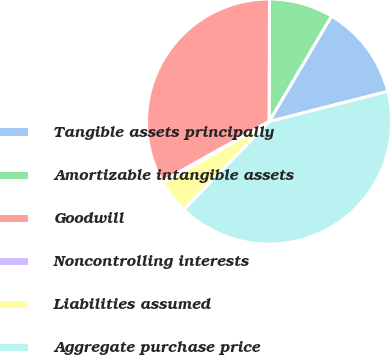<chart> <loc_0><loc_0><loc_500><loc_500><pie_chart><fcel>Tangible assets principally<fcel>Amortizable intangible assets<fcel>Goodwill<fcel>Noncontrolling interests<fcel>Liabilities assumed<fcel>Aggregate purchase price<nl><fcel>12.54%<fcel>8.45%<fcel>33.2%<fcel>0.26%<fcel>4.35%<fcel>41.21%<nl></chart> 